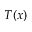Convert formula to latex. <formula><loc_0><loc_0><loc_500><loc_500>T ( x )</formula> 